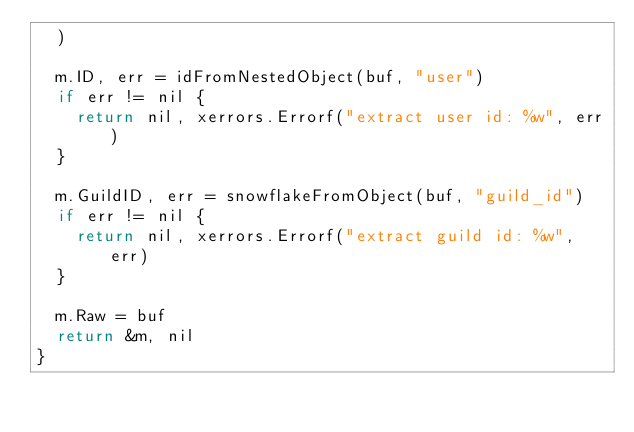Convert code to text. <code><loc_0><loc_0><loc_500><loc_500><_Go_>	)

	m.ID, err = idFromNestedObject(buf, "user")
	if err != nil {
		return nil, xerrors.Errorf("extract user id: %w", err)
	}

	m.GuildID, err = snowflakeFromObject(buf, "guild_id")
	if err != nil {
		return nil, xerrors.Errorf("extract guild id: %w", err)
	}

	m.Raw = buf
	return &m, nil
}
</code> 